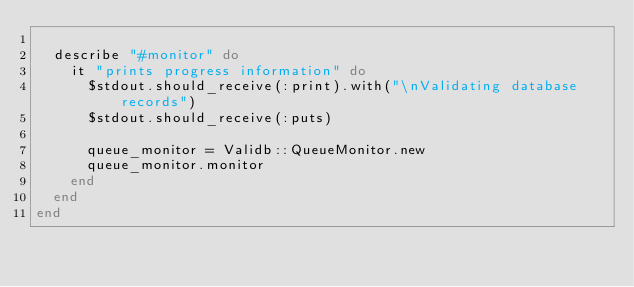<code> <loc_0><loc_0><loc_500><loc_500><_Ruby_>
  describe "#monitor" do
    it "prints progress information" do
      $stdout.should_receive(:print).with("\nValidating database records")
      $stdout.should_receive(:puts)

      queue_monitor = Validb::QueueMonitor.new
      queue_monitor.monitor
    end
  end
end
</code> 